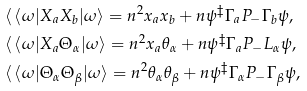<formula> <loc_0><loc_0><loc_500><loc_500>& \langle \, \langle \omega | X _ { a } X _ { b } | \omega \rangle = n ^ { 2 } x _ { a } x _ { b } + n \psi ^ { \ddagger } \Gamma _ { a } P _ { - } \Gamma _ { b } \psi , \\ & \langle \, \langle \omega | X _ { a } \Theta _ { \alpha } | \omega \rangle = n ^ { 2 } x _ { a } \theta _ { \alpha } + n \psi ^ { \ddagger } \Gamma _ { a } P _ { - } L _ { \alpha } \psi , \\ & \langle \, \langle \omega | \Theta _ { \alpha } \Theta _ { \beta } | \omega \rangle = n ^ { 2 } \theta _ { \alpha } \theta _ { \beta } + n \psi ^ { \ddagger } \Gamma _ { \alpha } P _ { - } \Gamma _ { \beta } \psi ,</formula> 